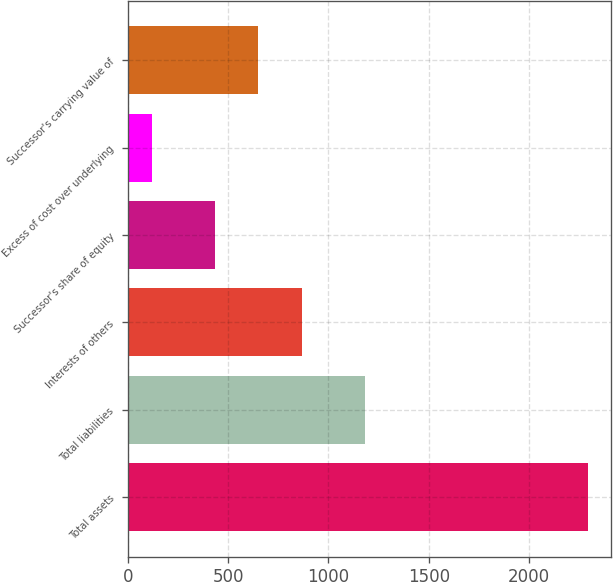Convert chart. <chart><loc_0><loc_0><loc_500><loc_500><bar_chart><fcel>Total assets<fcel>Total liabilities<fcel>Interests of others<fcel>Successor's share of equity<fcel>Excess of cost over underlying<fcel>Successor's carrying value of<nl><fcel>2295<fcel>1183<fcel>867.6<fcel>433<fcel>122<fcel>650.3<nl></chart> 